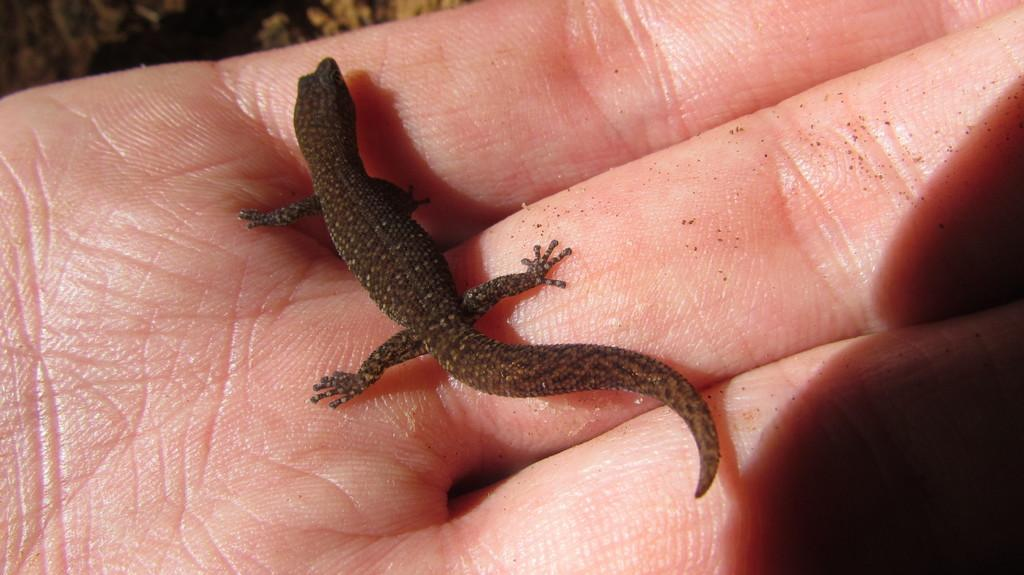What is present on the hand in the image? There is a lizard on the hand in the image. What color is the lizard? The lizard is black. Is the banana being held by the hand in the image? There is no banana present in the image. Is the person in the image taking a selfie with the lizard? There is not visible in the image, so it cannot be determined if the person is taking a selfie. 